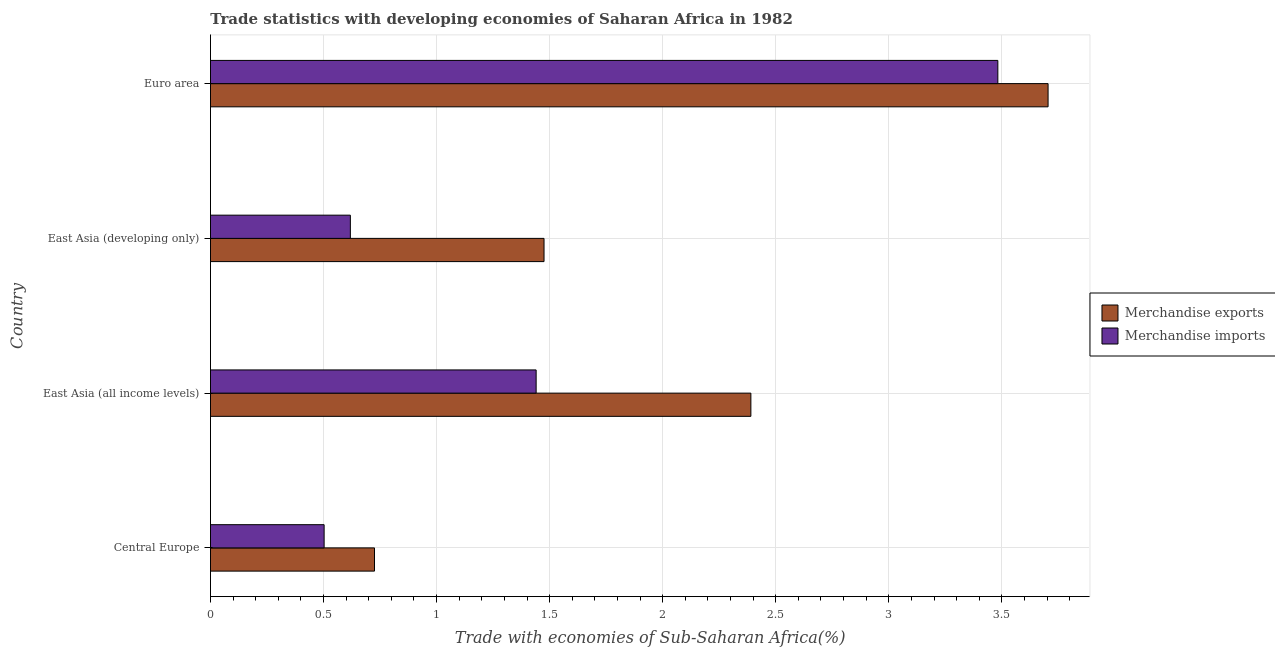How many groups of bars are there?
Provide a succinct answer. 4. Are the number of bars per tick equal to the number of legend labels?
Give a very brief answer. Yes. Are the number of bars on each tick of the Y-axis equal?
Provide a short and direct response. Yes. How many bars are there on the 2nd tick from the top?
Your answer should be very brief. 2. How many bars are there on the 4th tick from the bottom?
Make the answer very short. 2. What is the label of the 4th group of bars from the top?
Make the answer very short. Central Europe. What is the merchandise exports in East Asia (all income levels)?
Provide a short and direct response. 2.39. Across all countries, what is the maximum merchandise imports?
Keep it short and to the point. 3.48. Across all countries, what is the minimum merchandise exports?
Give a very brief answer. 0.73. In which country was the merchandise exports minimum?
Offer a terse response. Central Europe. What is the total merchandise imports in the graph?
Make the answer very short. 6.04. What is the difference between the merchandise exports in East Asia (all income levels) and that in East Asia (developing only)?
Ensure brevity in your answer.  0.92. What is the difference between the merchandise exports in Central Europe and the merchandise imports in East Asia (developing only)?
Your answer should be very brief. 0.11. What is the average merchandise exports per country?
Provide a succinct answer. 2.07. What is the difference between the merchandise imports and merchandise exports in East Asia (developing only)?
Provide a succinct answer. -0.86. In how many countries, is the merchandise exports greater than 2.4 %?
Give a very brief answer. 1. What is the ratio of the merchandise exports in Central Europe to that in Euro area?
Offer a terse response. 0.2. Is the merchandise exports in East Asia (all income levels) less than that in Euro area?
Provide a short and direct response. Yes. Is the difference between the merchandise imports in Central Europe and East Asia (developing only) greater than the difference between the merchandise exports in Central Europe and East Asia (developing only)?
Make the answer very short. Yes. What is the difference between the highest and the second highest merchandise exports?
Ensure brevity in your answer.  1.31. What is the difference between the highest and the lowest merchandise exports?
Make the answer very short. 2.98. Is the sum of the merchandise imports in Central Europe and East Asia (developing only) greater than the maximum merchandise exports across all countries?
Offer a very short reply. No. What does the 1st bar from the bottom in East Asia (all income levels) represents?
Make the answer very short. Merchandise exports. How many countries are there in the graph?
Your answer should be compact. 4. What is the difference between two consecutive major ticks on the X-axis?
Keep it short and to the point. 0.5. Does the graph contain grids?
Give a very brief answer. Yes. What is the title of the graph?
Keep it short and to the point. Trade statistics with developing economies of Saharan Africa in 1982. What is the label or title of the X-axis?
Offer a terse response. Trade with economies of Sub-Saharan Africa(%). What is the Trade with economies of Sub-Saharan Africa(%) of Merchandise exports in Central Europe?
Make the answer very short. 0.73. What is the Trade with economies of Sub-Saharan Africa(%) of Merchandise imports in Central Europe?
Offer a very short reply. 0.5. What is the Trade with economies of Sub-Saharan Africa(%) in Merchandise exports in East Asia (all income levels)?
Offer a very short reply. 2.39. What is the Trade with economies of Sub-Saharan Africa(%) in Merchandise imports in East Asia (all income levels)?
Offer a very short reply. 1.44. What is the Trade with economies of Sub-Saharan Africa(%) of Merchandise exports in East Asia (developing only)?
Offer a terse response. 1.48. What is the Trade with economies of Sub-Saharan Africa(%) in Merchandise imports in East Asia (developing only)?
Give a very brief answer. 0.62. What is the Trade with economies of Sub-Saharan Africa(%) in Merchandise exports in Euro area?
Ensure brevity in your answer.  3.7. What is the Trade with economies of Sub-Saharan Africa(%) in Merchandise imports in Euro area?
Your response must be concise. 3.48. Across all countries, what is the maximum Trade with economies of Sub-Saharan Africa(%) of Merchandise exports?
Keep it short and to the point. 3.7. Across all countries, what is the maximum Trade with economies of Sub-Saharan Africa(%) of Merchandise imports?
Your answer should be compact. 3.48. Across all countries, what is the minimum Trade with economies of Sub-Saharan Africa(%) in Merchandise exports?
Give a very brief answer. 0.73. Across all countries, what is the minimum Trade with economies of Sub-Saharan Africa(%) of Merchandise imports?
Your answer should be compact. 0.5. What is the total Trade with economies of Sub-Saharan Africa(%) of Merchandise exports in the graph?
Provide a succinct answer. 8.3. What is the total Trade with economies of Sub-Saharan Africa(%) in Merchandise imports in the graph?
Offer a terse response. 6.04. What is the difference between the Trade with economies of Sub-Saharan Africa(%) in Merchandise exports in Central Europe and that in East Asia (all income levels)?
Ensure brevity in your answer.  -1.66. What is the difference between the Trade with economies of Sub-Saharan Africa(%) in Merchandise imports in Central Europe and that in East Asia (all income levels)?
Make the answer very short. -0.94. What is the difference between the Trade with economies of Sub-Saharan Africa(%) in Merchandise exports in Central Europe and that in East Asia (developing only)?
Ensure brevity in your answer.  -0.75. What is the difference between the Trade with economies of Sub-Saharan Africa(%) of Merchandise imports in Central Europe and that in East Asia (developing only)?
Your response must be concise. -0.12. What is the difference between the Trade with economies of Sub-Saharan Africa(%) of Merchandise exports in Central Europe and that in Euro area?
Give a very brief answer. -2.98. What is the difference between the Trade with economies of Sub-Saharan Africa(%) of Merchandise imports in Central Europe and that in Euro area?
Your answer should be compact. -2.98. What is the difference between the Trade with economies of Sub-Saharan Africa(%) in Merchandise exports in East Asia (all income levels) and that in East Asia (developing only)?
Provide a succinct answer. 0.91. What is the difference between the Trade with economies of Sub-Saharan Africa(%) in Merchandise imports in East Asia (all income levels) and that in East Asia (developing only)?
Your response must be concise. 0.82. What is the difference between the Trade with economies of Sub-Saharan Africa(%) in Merchandise exports in East Asia (all income levels) and that in Euro area?
Your answer should be very brief. -1.31. What is the difference between the Trade with economies of Sub-Saharan Africa(%) in Merchandise imports in East Asia (all income levels) and that in Euro area?
Your answer should be very brief. -2.04. What is the difference between the Trade with economies of Sub-Saharan Africa(%) of Merchandise exports in East Asia (developing only) and that in Euro area?
Ensure brevity in your answer.  -2.23. What is the difference between the Trade with economies of Sub-Saharan Africa(%) of Merchandise imports in East Asia (developing only) and that in Euro area?
Offer a very short reply. -2.86. What is the difference between the Trade with economies of Sub-Saharan Africa(%) of Merchandise exports in Central Europe and the Trade with economies of Sub-Saharan Africa(%) of Merchandise imports in East Asia (all income levels)?
Your response must be concise. -0.71. What is the difference between the Trade with economies of Sub-Saharan Africa(%) of Merchandise exports in Central Europe and the Trade with economies of Sub-Saharan Africa(%) of Merchandise imports in East Asia (developing only)?
Offer a terse response. 0.11. What is the difference between the Trade with economies of Sub-Saharan Africa(%) in Merchandise exports in Central Europe and the Trade with economies of Sub-Saharan Africa(%) in Merchandise imports in Euro area?
Keep it short and to the point. -2.76. What is the difference between the Trade with economies of Sub-Saharan Africa(%) in Merchandise exports in East Asia (all income levels) and the Trade with economies of Sub-Saharan Africa(%) in Merchandise imports in East Asia (developing only)?
Make the answer very short. 1.77. What is the difference between the Trade with economies of Sub-Saharan Africa(%) in Merchandise exports in East Asia (all income levels) and the Trade with economies of Sub-Saharan Africa(%) in Merchandise imports in Euro area?
Provide a succinct answer. -1.09. What is the difference between the Trade with economies of Sub-Saharan Africa(%) in Merchandise exports in East Asia (developing only) and the Trade with economies of Sub-Saharan Africa(%) in Merchandise imports in Euro area?
Provide a succinct answer. -2.01. What is the average Trade with economies of Sub-Saharan Africa(%) of Merchandise exports per country?
Give a very brief answer. 2.07. What is the average Trade with economies of Sub-Saharan Africa(%) of Merchandise imports per country?
Your answer should be very brief. 1.51. What is the difference between the Trade with economies of Sub-Saharan Africa(%) in Merchandise exports and Trade with economies of Sub-Saharan Africa(%) in Merchandise imports in Central Europe?
Make the answer very short. 0.22. What is the difference between the Trade with economies of Sub-Saharan Africa(%) of Merchandise exports and Trade with economies of Sub-Saharan Africa(%) of Merchandise imports in East Asia (all income levels)?
Keep it short and to the point. 0.95. What is the difference between the Trade with economies of Sub-Saharan Africa(%) of Merchandise exports and Trade with economies of Sub-Saharan Africa(%) of Merchandise imports in East Asia (developing only)?
Provide a short and direct response. 0.86. What is the difference between the Trade with economies of Sub-Saharan Africa(%) in Merchandise exports and Trade with economies of Sub-Saharan Africa(%) in Merchandise imports in Euro area?
Provide a succinct answer. 0.22. What is the ratio of the Trade with economies of Sub-Saharan Africa(%) of Merchandise exports in Central Europe to that in East Asia (all income levels)?
Provide a short and direct response. 0.3. What is the ratio of the Trade with economies of Sub-Saharan Africa(%) of Merchandise imports in Central Europe to that in East Asia (all income levels)?
Your answer should be very brief. 0.35. What is the ratio of the Trade with economies of Sub-Saharan Africa(%) in Merchandise exports in Central Europe to that in East Asia (developing only)?
Give a very brief answer. 0.49. What is the ratio of the Trade with economies of Sub-Saharan Africa(%) in Merchandise imports in Central Europe to that in East Asia (developing only)?
Ensure brevity in your answer.  0.81. What is the ratio of the Trade with economies of Sub-Saharan Africa(%) in Merchandise exports in Central Europe to that in Euro area?
Your response must be concise. 0.2. What is the ratio of the Trade with economies of Sub-Saharan Africa(%) of Merchandise imports in Central Europe to that in Euro area?
Provide a succinct answer. 0.14. What is the ratio of the Trade with economies of Sub-Saharan Africa(%) in Merchandise exports in East Asia (all income levels) to that in East Asia (developing only)?
Your answer should be compact. 1.62. What is the ratio of the Trade with economies of Sub-Saharan Africa(%) of Merchandise imports in East Asia (all income levels) to that in East Asia (developing only)?
Provide a succinct answer. 2.33. What is the ratio of the Trade with economies of Sub-Saharan Africa(%) in Merchandise exports in East Asia (all income levels) to that in Euro area?
Provide a succinct answer. 0.65. What is the ratio of the Trade with economies of Sub-Saharan Africa(%) of Merchandise imports in East Asia (all income levels) to that in Euro area?
Offer a terse response. 0.41. What is the ratio of the Trade with economies of Sub-Saharan Africa(%) of Merchandise exports in East Asia (developing only) to that in Euro area?
Offer a very short reply. 0.4. What is the ratio of the Trade with economies of Sub-Saharan Africa(%) in Merchandise imports in East Asia (developing only) to that in Euro area?
Offer a very short reply. 0.18. What is the difference between the highest and the second highest Trade with economies of Sub-Saharan Africa(%) in Merchandise exports?
Ensure brevity in your answer.  1.31. What is the difference between the highest and the second highest Trade with economies of Sub-Saharan Africa(%) of Merchandise imports?
Provide a short and direct response. 2.04. What is the difference between the highest and the lowest Trade with economies of Sub-Saharan Africa(%) of Merchandise exports?
Provide a short and direct response. 2.98. What is the difference between the highest and the lowest Trade with economies of Sub-Saharan Africa(%) in Merchandise imports?
Your answer should be very brief. 2.98. 